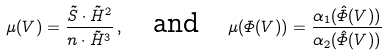<formula> <loc_0><loc_0><loc_500><loc_500>\mu ( V ) = \frac { \tilde { S } \cdot \tilde { H } ^ { 2 } } { n \cdot \tilde { H } ^ { 3 } } \, , \quad \text {and} \quad \mu ( { \varPhi } ( V ) ) = \frac { \alpha _ { 1 } ( \hat { \varPhi } ( V ) ) } { \alpha _ { 2 } ( \hat { \varPhi } ( V ) ) }</formula> 